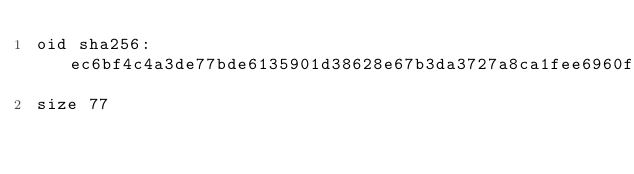<code> <loc_0><loc_0><loc_500><loc_500><_YAML_>oid sha256:ec6bf4c4a3de77bde6135901d38628e67b3da3727a8ca1fee6960fadd1703017
size 77
</code> 